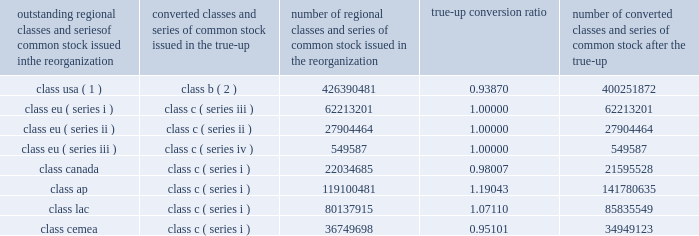Visa inc .
Notes to consolidated financial statements 2014 ( continued ) september 30 , 2008 ( in millions , except as noted ) were converted on a one-to-one basis from class eu ( series i , ii , iii ) common stock to class c ( series iii , ii , and iv ) common stock concurrent with the true-up .
The results of the true-up are reflected in the table below .
Fractional shares resulting from the conversion of the shares of each individual stockholder have been rounded down .
These fractional shares were paid in cash to stockholders as part of the initial redemption of class b common stock and class c common stock shortly following the ipo .
Outstanding regional classes and series of common stock issued in the reorganization converted classes and series of common stock issued in the true-up number of regional classes and series of common stock issued in the reorganization true-up conversion number of converted classes and series of common stock after the true-up class usa ( 1 ) class b ( 2 ) 426390481 0.93870 400251872 .
( 1 ) the amount of the class usa common stock outstanding prior to the true-up is net of 131592008 shares held by wholly-owned subsidiaries of the company .
( 2 ) the amount of the class b common stock outstanding subsequent to the true-up is net of 123525418 shares held by wholly-owned subsidiaries of the company .
Also , the company issued 51844393 additional shares of class c ( series ii ) common stock at a price of $ 44 per share in exchange for a subscription receivable from visa europe .
This issuance and subscription receivable were recorded as offsetting entries in temporary equity on the company 2019s consolidated balance sheet at september 30 , 2008 .
Initial public offering in march 2008 , the company completed its ipo with the issuance of 446600000 shares of class a common stock at a net offering price of $ 42.77 ( the ipo price of $ 44.00 per share of class a common stock , less underwriting discounts and commissions of $ 1.23 per share ) .
The company received net proceeds of $ 19.1 billion as a result of the ipo. .
What is the difference in the number of class usa stock of pre and after true-up? 
Computations: (426390481 - 400251872)
Answer: 26138609.0. 